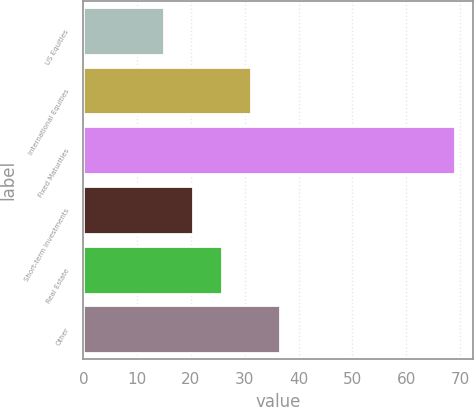Convert chart. <chart><loc_0><loc_0><loc_500><loc_500><bar_chart><fcel>US Equities<fcel>International Equities<fcel>Fixed Maturities<fcel>Short-term Investments<fcel>Real Estate<fcel>Other<nl><fcel>15<fcel>31.2<fcel>69<fcel>20.4<fcel>25.8<fcel>36.6<nl></chart> 